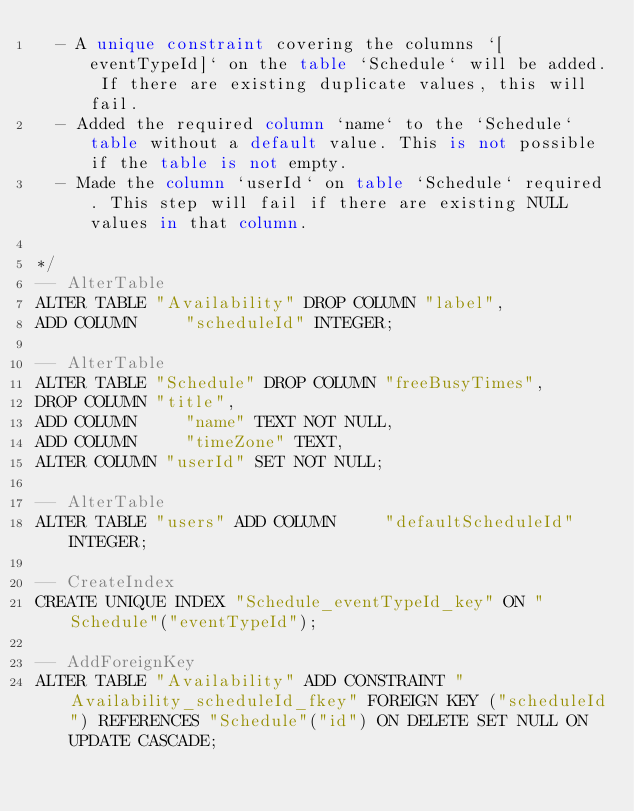Convert code to text. <code><loc_0><loc_0><loc_500><loc_500><_SQL_>  - A unique constraint covering the columns `[eventTypeId]` on the table `Schedule` will be added. If there are existing duplicate values, this will fail.
  - Added the required column `name` to the `Schedule` table without a default value. This is not possible if the table is not empty.
  - Made the column `userId` on table `Schedule` required. This step will fail if there are existing NULL values in that column.

*/
-- AlterTable
ALTER TABLE "Availability" DROP COLUMN "label",
ADD COLUMN     "scheduleId" INTEGER;

-- AlterTable
ALTER TABLE "Schedule" DROP COLUMN "freeBusyTimes",
DROP COLUMN "title",
ADD COLUMN     "name" TEXT NOT NULL,
ADD COLUMN     "timeZone" TEXT,
ALTER COLUMN "userId" SET NOT NULL;

-- AlterTable
ALTER TABLE "users" ADD COLUMN     "defaultScheduleId" INTEGER;

-- CreateIndex
CREATE UNIQUE INDEX "Schedule_eventTypeId_key" ON "Schedule"("eventTypeId");

-- AddForeignKey
ALTER TABLE "Availability" ADD CONSTRAINT "Availability_scheduleId_fkey" FOREIGN KEY ("scheduleId") REFERENCES "Schedule"("id") ON DELETE SET NULL ON UPDATE CASCADE;
</code> 